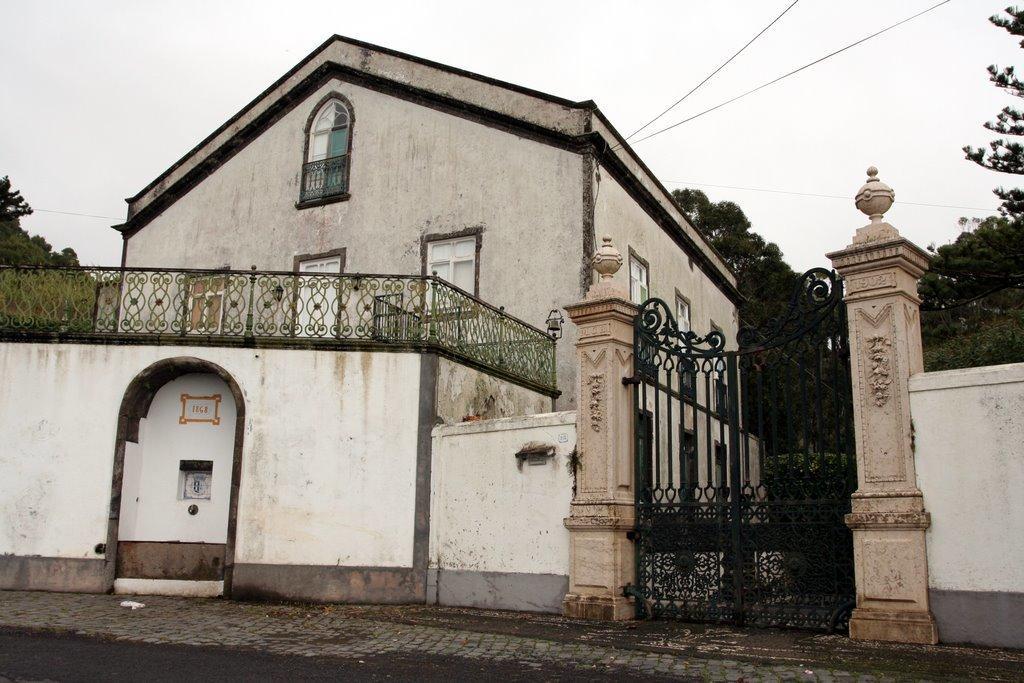Please provide a concise description of this image. As we can see in the image there is a building. The building has four windows 1, 2, 3, and 4. On the right side there are some trees and a door. On the left side there is a tree. On the top there is a sky. In front of building there is a road. 